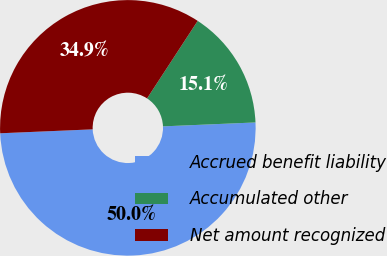<chart> <loc_0><loc_0><loc_500><loc_500><pie_chart><fcel>Accrued benefit liability<fcel>Accumulated other<fcel>Net amount recognized<nl><fcel>50.0%<fcel>15.12%<fcel>34.88%<nl></chart> 